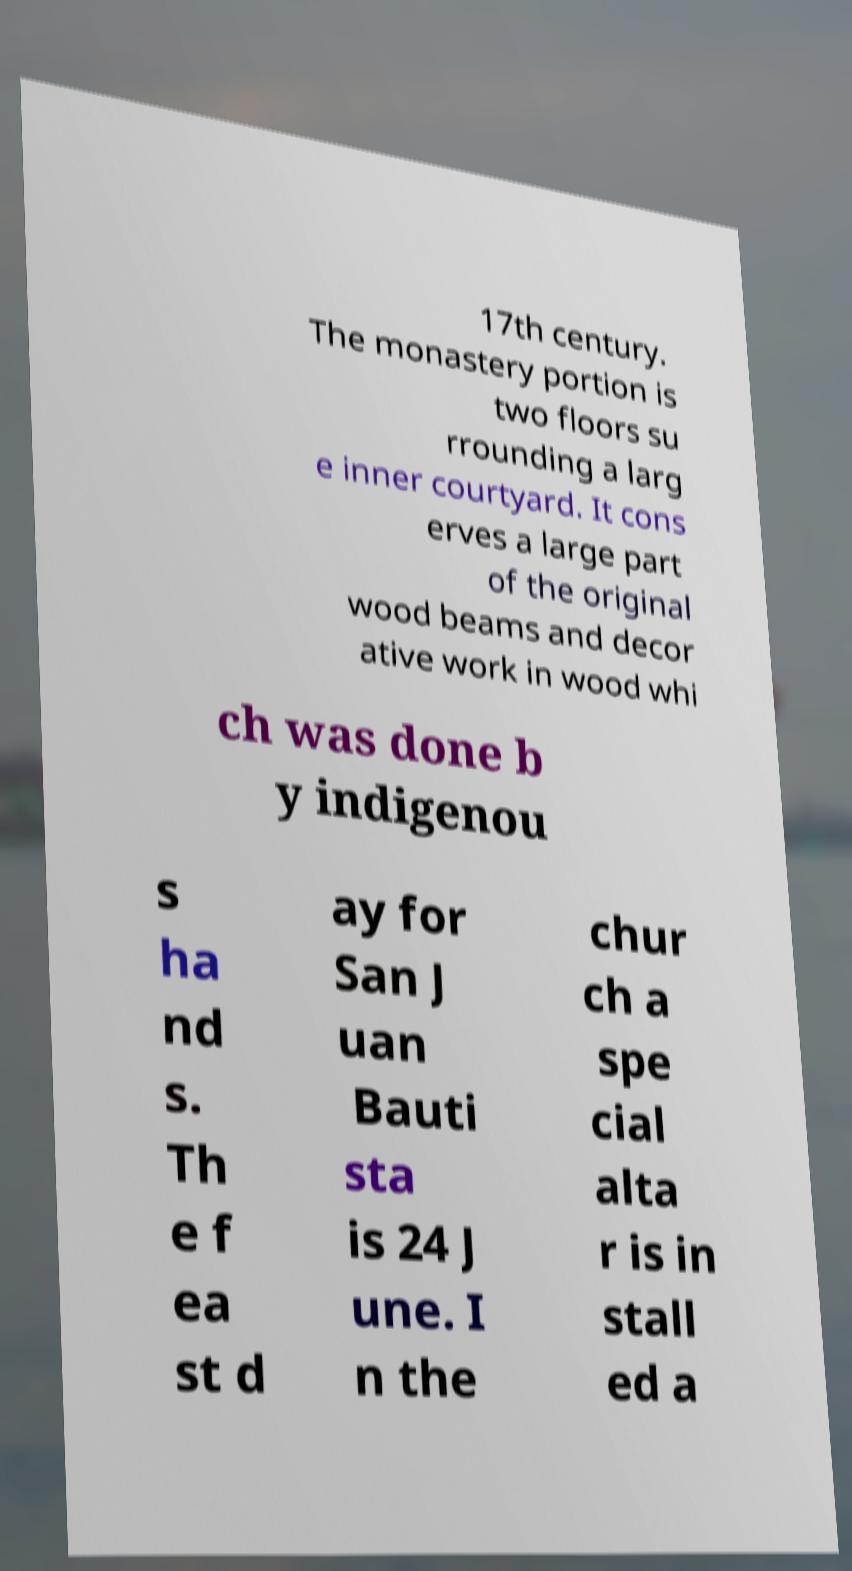What messages or text are displayed in this image? I need them in a readable, typed format. 17th century. The monastery portion is two floors su rrounding a larg e inner courtyard. It cons erves a large part of the original wood beams and decor ative work in wood whi ch was done b y indigenou s ha nd s. Th e f ea st d ay for San J uan Bauti sta is 24 J une. I n the chur ch a spe cial alta r is in stall ed a 